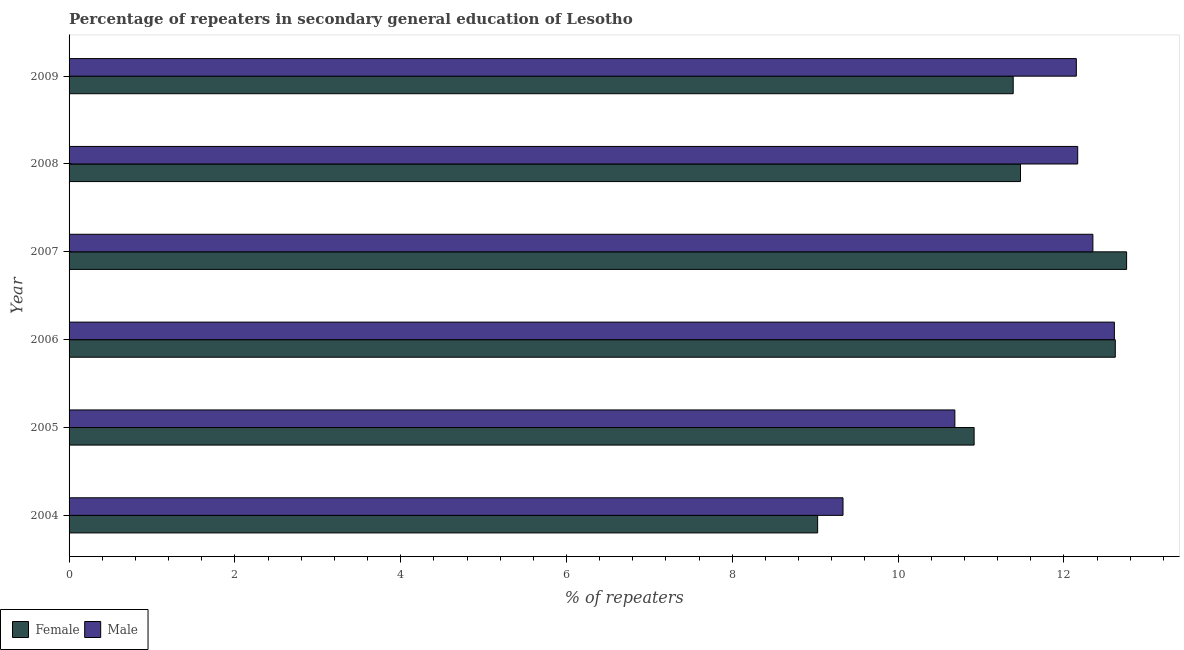How many groups of bars are there?
Your answer should be very brief. 6. Are the number of bars per tick equal to the number of legend labels?
Your answer should be very brief. Yes. Are the number of bars on each tick of the Y-axis equal?
Provide a short and direct response. Yes. What is the label of the 5th group of bars from the top?
Your answer should be compact. 2005. What is the percentage of female repeaters in 2006?
Offer a very short reply. 12.62. Across all years, what is the maximum percentage of male repeaters?
Offer a very short reply. 12.61. Across all years, what is the minimum percentage of female repeaters?
Your answer should be very brief. 9.03. In which year was the percentage of male repeaters maximum?
Offer a very short reply. 2006. In which year was the percentage of female repeaters minimum?
Provide a short and direct response. 2004. What is the total percentage of female repeaters in the graph?
Offer a very short reply. 68.19. What is the difference between the percentage of female repeaters in 2004 and that in 2009?
Give a very brief answer. -2.36. What is the difference between the percentage of male repeaters in 2008 and the percentage of female repeaters in 2007?
Offer a terse response. -0.59. What is the average percentage of female repeaters per year?
Ensure brevity in your answer.  11.37. In the year 2007, what is the difference between the percentage of male repeaters and percentage of female repeaters?
Your answer should be compact. -0.41. In how many years, is the percentage of female repeaters greater than 12 %?
Keep it short and to the point. 2. What is the ratio of the percentage of female repeaters in 2006 to that in 2009?
Offer a terse response. 1.11. What is the difference between the highest and the second highest percentage of male repeaters?
Make the answer very short. 0.26. What is the difference between the highest and the lowest percentage of female repeaters?
Provide a short and direct response. 3.73. Is the sum of the percentage of female repeaters in 2004 and 2006 greater than the maximum percentage of male repeaters across all years?
Provide a short and direct response. Yes. Are all the bars in the graph horizontal?
Your answer should be compact. Yes. Are the values on the major ticks of X-axis written in scientific E-notation?
Give a very brief answer. No. Does the graph contain any zero values?
Your response must be concise. No. Where does the legend appear in the graph?
Offer a very short reply. Bottom left. What is the title of the graph?
Ensure brevity in your answer.  Percentage of repeaters in secondary general education of Lesotho. What is the label or title of the X-axis?
Ensure brevity in your answer.  % of repeaters. What is the label or title of the Y-axis?
Ensure brevity in your answer.  Year. What is the % of repeaters of Female in 2004?
Your answer should be compact. 9.03. What is the % of repeaters in Male in 2004?
Give a very brief answer. 9.34. What is the % of repeaters of Female in 2005?
Your answer should be very brief. 10.92. What is the % of repeaters of Male in 2005?
Make the answer very short. 10.68. What is the % of repeaters of Female in 2006?
Make the answer very short. 12.62. What is the % of repeaters of Male in 2006?
Give a very brief answer. 12.61. What is the % of repeaters in Female in 2007?
Offer a very short reply. 12.76. What is the % of repeaters of Male in 2007?
Provide a succinct answer. 12.35. What is the % of repeaters of Female in 2008?
Provide a short and direct response. 11.48. What is the % of repeaters of Male in 2008?
Keep it short and to the point. 12.17. What is the % of repeaters in Female in 2009?
Provide a short and direct response. 11.39. What is the % of repeaters of Male in 2009?
Keep it short and to the point. 12.15. Across all years, what is the maximum % of repeaters of Female?
Your answer should be compact. 12.76. Across all years, what is the maximum % of repeaters in Male?
Ensure brevity in your answer.  12.61. Across all years, what is the minimum % of repeaters in Female?
Offer a very short reply. 9.03. Across all years, what is the minimum % of repeaters of Male?
Give a very brief answer. 9.34. What is the total % of repeaters of Female in the graph?
Offer a very short reply. 68.19. What is the total % of repeaters of Male in the graph?
Your response must be concise. 69.3. What is the difference between the % of repeaters of Female in 2004 and that in 2005?
Offer a terse response. -1.89. What is the difference between the % of repeaters of Male in 2004 and that in 2005?
Your answer should be very brief. -1.35. What is the difference between the % of repeaters of Female in 2004 and that in 2006?
Offer a terse response. -3.59. What is the difference between the % of repeaters of Male in 2004 and that in 2006?
Ensure brevity in your answer.  -3.27. What is the difference between the % of repeaters in Female in 2004 and that in 2007?
Offer a very short reply. -3.73. What is the difference between the % of repeaters of Male in 2004 and that in 2007?
Make the answer very short. -3.01. What is the difference between the % of repeaters of Female in 2004 and that in 2008?
Offer a terse response. -2.45. What is the difference between the % of repeaters in Male in 2004 and that in 2008?
Your response must be concise. -2.83. What is the difference between the % of repeaters of Female in 2004 and that in 2009?
Provide a short and direct response. -2.36. What is the difference between the % of repeaters in Male in 2004 and that in 2009?
Make the answer very short. -2.81. What is the difference between the % of repeaters of Female in 2005 and that in 2006?
Keep it short and to the point. -1.7. What is the difference between the % of repeaters of Male in 2005 and that in 2006?
Provide a short and direct response. -1.92. What is the difference between the % of repeaters of Female in 2005 and that in 2007?
Provide a succinct answer. -1.84. What is the difference between the % of repeaters in Male in 2005 and that in 2007?
Provide a succinct answer. -1.66. What is the difference between the % of repeaters in Female in 2005 and that in 2008?
Offer a terse response. -0.56. What is the difference between the % of repeaters in Male in 2005 and that in 2008?
Provide a succinct answer. -1.48. What is the difference between the % of repeaters of Female in 2005 and that in 2009?
Offer a very short reply. -0.47. What is the difference between the % of repeaters in Male in 2005 and that in 2009?
Make the answer very short. -1.47. What is the difference between the % of repeaters of Female in 2006 and that in 2007?
Make the answer very short. -0.14. What is the difference between the % of repeaters of Male in 2006 and that in 2007?
Your answer should be compact. 0.26. What is the difference between the % of repeaters of Female in 2006 and that in 2008?
Keep it short and to the point. 1.14. What is the difference between the % of repeaters of Male in 2006 and that in 2008?
Keep it short and to the point. 0.44. What is the difference between the % of repeaters in Female in 2006 and that in 2009?
Ensure brevity in your answer.  1.23. What is the difference between the % of repeaters in Male in 2006 and that in 2009?
Keep it short and to the point. 0.46. What is the difference between the % of repeaters of Female in 2007 and that in 2008?
Ensure brevity in your answer.  1.28. What is the difference between the % of repeaters in Male in 2007 and that in 2008?
Provide a succinct answer. 0.18. What is the difference between the % of repeaters of Female in 2007 and that in 2009?
Your answer should be compact. 1.37. What is the difference between the % of repeaters in Male in 2007 and that in 2009?
Keep it short and to the point. 0.2. What is the difference between the % of repeaters in Female in 2008 and that in 2009?
Keep it short and to the point. 0.09. What is the difference between the % of repeaters in Male in 2008 and that in 2009?
Give a very brief answer. 0.02. What is the difference between the % of repeaters in Female in 2004 and the % of repeaters in Male in 2005?
Offer a very short reply. -1.66. What is the difference between the % of repeaters in Female in 2004 and the % of repeaters in Male in 2006?
Your response must be concise. -3.58. What is the difference between the % of repeaters of Female in 2004 and the % of repeaters of Male in 2007?
Offer a terse response. -3.32. What is the difference between the % of repeaters in Female in 2004 and the % of repeaters in Male in 2008?
Make the answer very short. -3.14. What is the difference between the % of repeaters in Female in 2004 and the % of repeaters in Male in 2009?
Your answer should be compact. -3.12. What is the difference between the % of repeaters in Female in 2005 and the % of repeaters in Male in 2006?
Offer a terse response. -1.69. What is the difference between the % of repeaters in Female in 2005 and the % of repeaters in Male in 2007?
Your answer should be very brief. -1.43. What is the difference between the % of repeaters in Female in 2005 and the % of repeaters in Male in 2008?
Ensure brevity in your answer.  -1.25. What is the difference between the % of repeaters in Female in 2005 and the % of repeaters in Male in 2009?
Offer a terse response. -1.23. What is the difference between the % of repeaters of Female in 2006 and the % of repeaters of Male in 2007?
Your response must be concise. 0.27. What is the difference between the % of repeaters in Female in 2006 and the % of repeaters in Male in 2008?
Offer a very short reply. 0.45. What is the difference between the % of repeaters in Female in 2006 and the % of repeaters in Male in 2009?
Offer a terse response. 0.47. What is the difference between the % of repeaters in Female in 2007 and the % of repeaters in Male in 2008?
Your answer should be very brief. 0.59. What is the difference between the % of repeaters in Female in 2007 and the % of repeaters in Male in 2009?
Your answer should be compact. 0.61. What is the difference between the % of repeaters in Female in 2008 and the % of repeaters in Male in 2009?
Your answer should be very brief. -0.67. What is the average % of repeaters in Female per year?
Offer a terse response. 11.36. What is the average % of repeaters in Male per year?
Your answer should be compact. 11.55. In the year 2004, what is the difference between the % of repeaters of Female and % of repeaters of Male?
Provide a short and direct response. -0.31. In the year 2005, what is the difference between the % of repeaters of Female and % of repeaters of Male?
Your answer should be compact. 0.23. In the year 2006, what is the difference between the % of repeaters in Female and % of repeaters in Male?
Offer a very short reply. 0.01. In the year 2007, what is the difference between the % of repeaters of Female and % of repeaters of Male?
Ensure brevity in your answer.  0.41. In the year 2008, what is the difference between the % of repeaters of Female and % of repeaters of Male?
Ensure brevity in your answer.  -0.69. In the year 2009, what is the difference between the % of repeaters in Female and % of repeaters in Male?
Ensure brevity in your answer.  -0.76. What is the ratio of the % of repeaters of Female in 2004 to that in 2005?
Ensure brevity in your answer.  0.83. What is the ratio of the % of repeaters in Male in 2004 to that in 2005?
Your answer should be very brief. 0.87. What is the ratio of the % of repeaters in Female in 2004 to that in 2006?
Your answer should be compact. 0.72. What is the ratio of the % of repeaters of Male in 2004 to that in 2006?
Keep it short and to the point. 0.74. What is the ratio of the % of repeaters of Female in 2004 to that in 2007?
Your response must be concise. 0.71. What is the ratio of the % of repeaters of Male in 2004 to that in 2007?
Your response must be concise. 0.76. What is the ratio of the % of repeaters of Female in 2004 to that in 2008?
Your response must be concise. 0.79. What is the ratio of the % of repeaters of Male in 2004 to that in 2008?
Your response must be concise. 0.77. What is the ratio of the % of repeaters of Female in 2004 to that in 2009?
Make the answer very short. 0.79. What is the ratio of the % of repeaters in Male in 2004 to that in 2009?
Ensure brevity in your answer.  0.77. What is the ratio of the % of repeaters of Female in 2005 to that in 2006?
Make the answer very short. 0.87. What is the ratio of the % of repeaters in Male in 2005 to that in 2006?
Provide a succinct answer. 0.85. What is the ratio of the % of repeaters in Female in 2005 to that in 2007?
Your response must be concise. 0.86. What is the ratio of the % of repeaters of Male in 2005 to that in 2007?
Your response must be concise. 0.87. What is the ratio of the % of repeaters of Female in 2005 to that in 2008?
Offer a very short reply. 0.95. What is the ratio of the % of repeaters of Male in 2005 to that in 2008?
Your response must be concise. 0.88. What is the ratio of the % of repeaters of Female in 2005 to that in 2009?
Ensure brevity in your answer.  0.96. What is the ratio of the % of repeaters in Male in 2005 to that in 2009?
Keep it short and to the point. 0.88. What is the ratio of the % of repeaters of Female in 2006 to that in 2007?
Give a very brief answer. 0.99. What is the ratio of the % of repeaters in Male in 2006 to that in 2007?
Provide a short and direct response. 1.02. What is the ratio of the % of repeaters in Female in 2006 to that in 2008?
Your answer should be very brief. 1.1. What is the ratio of the % of repeaters in Male in 2006 to that in 2008?
Give a very brief answer. 1.04. What is the ratio of the % of repeaters in Female in 2006 to that in 2009?
Offer a terse response. 1.11. What is the ratio of the % of repeaters of Male in 2006 to that in 2009?
Make the answer very short. 1.04. What is the ratio of the % of repeaters of Female in 2007 to that in 2008?
Offer a very short reply. 1.11. What is the ratio of the % of repeaters in Male in 2007 to that in 2008?
Your answer should be compact. 1.02. What is the ratio of the % of repeaters of Female in 2007 to that in 2009?
Provide a short and direct response. 1.12. What is the ratio of the % of repeaters in Male in 2007 to that in 2009?
Ensure brevity in your answer.  1.02. What is the ratio of the % of repeaters of Female in 2008 to that in 2009?
Keep it short and to the point. 1.01. What is the ratio of the % of repeaters of Male in 2008 to that in 2009?
Offer a terse response. 1. What is the difference between the highest and the second highest % of repeaters of Female?
Give a very brief answer. 0.14. What is the difference between the highest and the second highest % of repeaters in Male?
Your response must be concise. 0.26. What is the difference between the highest and the lowest % of repeaters in Female?
Your answer should be very brief. 3.73. What is the difference between the highest and the lowest % of repeaters of Male?
Provide a short and direct response. 3.27. 